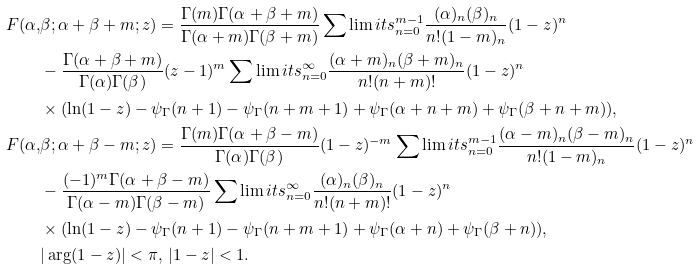Convert formula to latex. <formula><loc_0><loc_0><loc_500><loc_500>F ( \alpha , & \beta ; \alpha + \beta + m ; z ) = \frac { \Gamma ( m ) \Gamma ( \alpha + \beta + m ) } { \Gamma ( \alpha + m ) \Gamma ( \beta + m ) } \sum \lim i t s _ { n = 0 } ^ { m - 1 } \frac { ( \alpha ) _ { n } ( \beta ) _ { n } } { n ! ( 1 - m ) _ { n } } ( 1 - z ) ^ { n } \\ & - \frac { \Gamma ( \alpha + \beta + m ) } { \Gamma ( \alpha ) \Gamma ( \beta ) } ( z - 1 ) ^ { m } \sum \lim i t s _ { n = 0 } ^ { \infty } \frac { ( \alpha + m ) _ { n } ( \beta + m ) _ { n } } { n ! ( n + m ) ! } ( 1 - z ) ^ { n } \\ & \times ( \ln ( 1 - z ) - \psi _ { \Gamma } ( n + 1 ) - \psi _ { \Gamma } ( n + m + 1 ) + \psi _ { \Gamma } ( \alpha + n + m ) + \psi _ { \Gamma } ( \beta + n + m ) ) , \\ F ( \alpha , & \beta ; \alpha + \beta - m ; z ) = \frac { \Gamma ( m ) \Gamma ( \alpha + \beta - m ) } { \Gamma ( \alpha ) \Gamma ( \beta ) } ( 1 - z ) ^ { - m } \sum \lim i t s _ { n = 0 } ^ { m - 1 } \frac { ( \alpha - m ) _ { n } ( \beta - m ) _ { n } } { n ! ( 1 - m ) _ { n } } ( 1 - z ) ^ { n } \\ & - \frac { ( - 1 ) ^ { m } \Gamma ( \alpha + \beta - m ) } { \Gamma ( \alpha - m ) \Gamma ( \beta - m ) } \sum \lim i t s _ { n = 0 } ^ { \infty } \frac { ( \alpha ) _ { n } ( \beta ) _ { n } } { n ! ( n + m ) ! } ( 1 - z ) ^ { n } \\ & \times ( \ln ( 1 - z ) - \psi _ { \Gamma } ( n + 1 ) - \psi _ { \Gamma } ( n + m + 1 ) + \psi _ { \Gamma } ( \alpha + n ) + \psi _ { \Gamma } ( \beta + n ) ) , \\ & | \arg ( 1 - z ) | < \pi , \, | 1 - z | < 1 .</formula> 